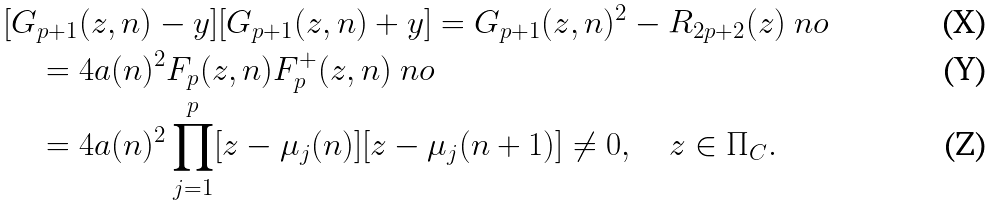<formula> <loc_0><loc_0><loc_500><loc_500>& [ G _ { p + 1 } ( z , n ) - y ] [ G _ { p + 1 } ( z , n ) + y ] = G _ { p + 1 } ( z , n ) ^ { 2 } - R _ { 2 p + 2 } ( z ) \ n o \\ & \quad = 4 a ( n ) ^ { 2 } F _ { p } ( z , n ) F _ { p } ^ { + } ( z , n ) \ n o \\ & \quad = 4 a ( n ) ^ { 2 } \prod _ { j = 1 } ^ { p } [ z - \mu _ { j } ( n ) ] [ z - \mu _ { j } ( n + 1 ) ] \neq 0 , \quad z \in \Pi _ { C } .</formula> 